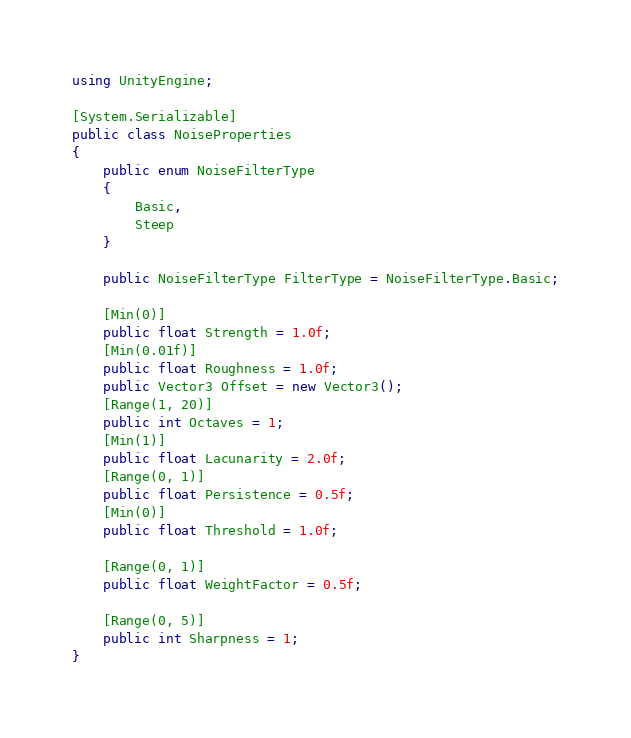<code> <loc_0><loc_0><loc_500><loc_500><_C#_>using UnityEngine;

[System.Serializable]
public class NoiseProperties 
{
    public enum NoiseFilterType
    {
        Basic,
        Steep
    }

    public NoiseFilterType FilterType = NoiseFilterType.Basic;

    [Min(0)]
    public float Strength = 1.0f;
    [Min(0.01f)]
    public float Roughness = 1.0f;
    public Vector3 Offset = new Vector3();
    [Range(1, 20)]
    public int Octaves = 1;
    [Min(1)]
    public float Lacunarity = 2.0f;
    [Range(0, 1)]
    public float Persistence = 0.5f;
    [Min(0)]
    public float Threshold = 1.0f;

    [Range(0, 1)]
    public float WeightFactor = 0.5f;

    [Range(0, 5)]
    public int Sharpness = 1;
}
</code> 